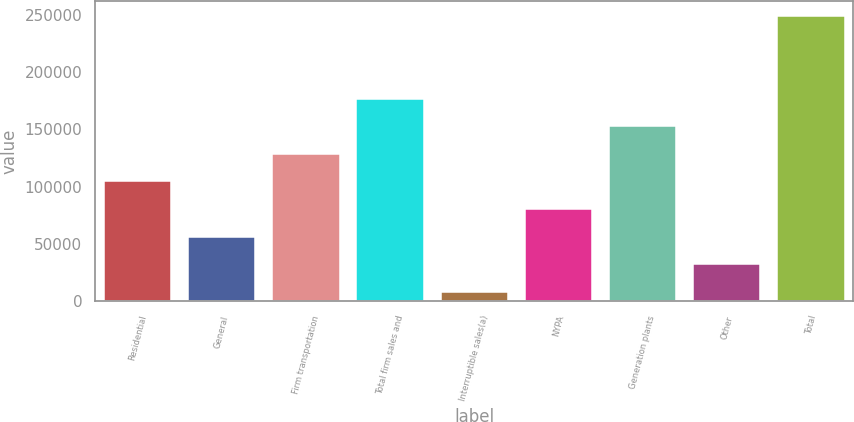Convert chart to OTSL. <chart><loc_0><loc_0><loc_500><loc_500><bar_chart><fcel>Residential<fcel>General<fcel>Firm transportation<fcel>Total firm sales and<fcel>Interruptible sales(a)<fcel>NYPA<fcel>Generation plants<fcel>Other<fcel>Total<nl><fcel>104578<fcel>56401.6<fcel>128666<fcel>176843<fcel>8225<fcel>80489.9<fcel>152755<fcel>32313.3<fcel>249108<nl></chart> 